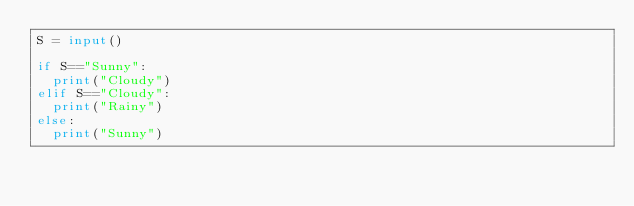<code> <loc_0><loc_0><loc_500><loc_500><_Python_>S = input()

if S=="Sunny":
  print("Cloudy")
elif S=="Cloudy":
  print("Rainy")
else:
  print("Sunny")</code> 